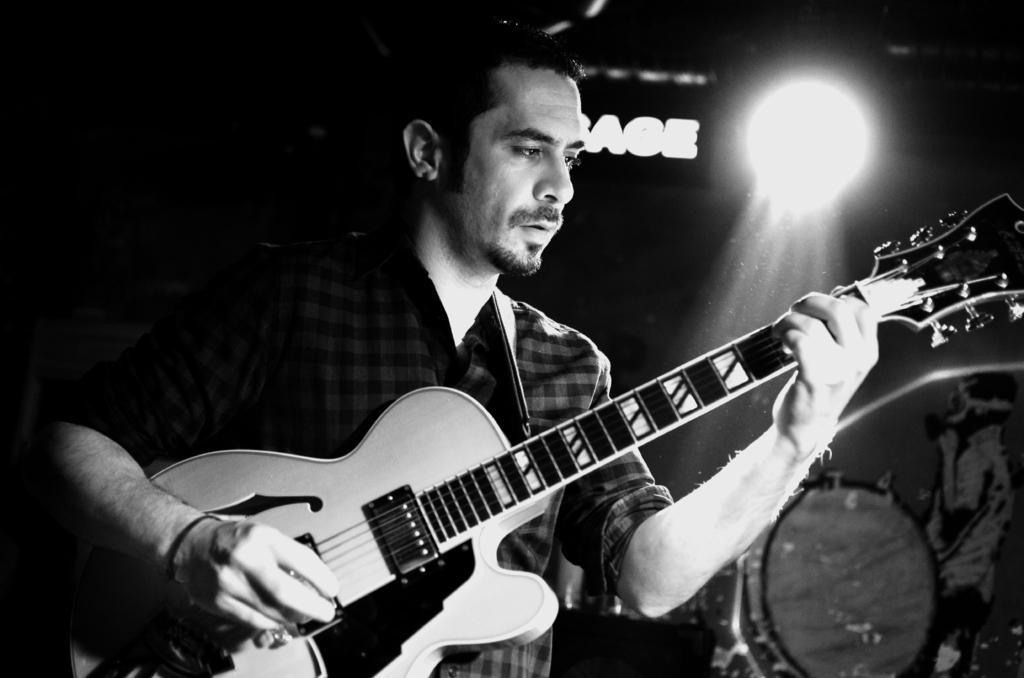In one or two sentences, can you explain what this image depicts? In this picture a man is holding a guitar with his left hand and playing the guitar with his right hand, he is looking at the guitar 